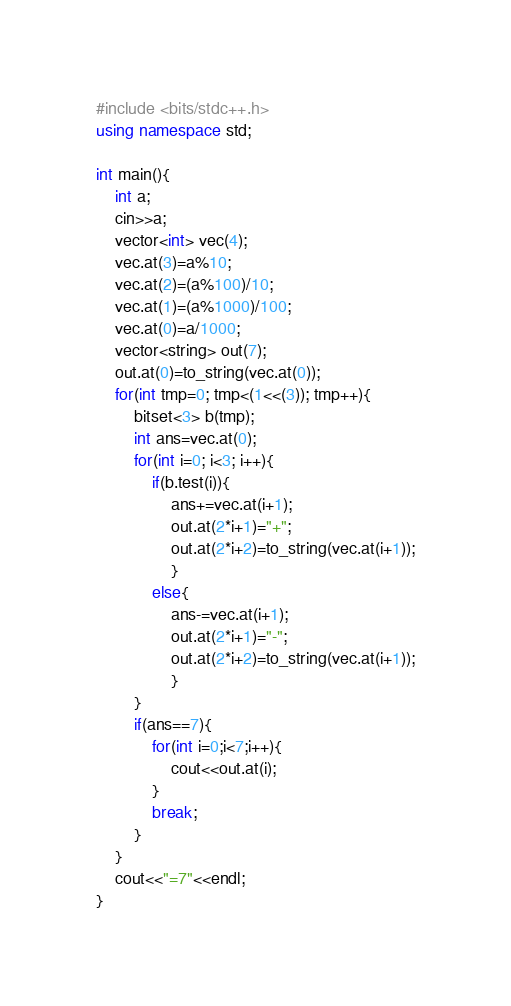Convert code to text. <code><loc_0><loc_0><loc_500><loc_500><_C++_>#include <bits/stdc++.h>
using namespace std;

int main(){
    int a;
    cin>>a;
    vector<int> vec(4);
    vec.at(3)=a%10;
    vec.at(2)=(a%100)/10;
    vec.at(1)=(a%1000)/100;
    vec.at(0)=a/1000;
    vector<string> out(7);
    out.at(0)=to_string(vec.at(0));
    for(int tmp=0; tmp<(1<<(3)); tmp++){
        bitset<3> b(tmp);
        int ans=vec.at(0);
        for(int i=0; i<3; i++){
            if(b.test(i)){
                ans+=vec.at(i+1);
                out.at(2*i+1)="+";
                out.at(2*i+2)=to_string(vec.at(i+1));
                }
            else{
                ans-=vec.at(i+1);
                out.at(2*i+1)="-";
                out.at(2*i+2)=to_string(vec.at(i+1));
                }
        }
        if(ans==7){
            for(int i=0;i<7;i++){
                cout<<out.at(i);
            }
            break;
        }
    }
    cout<<"=7"<<endl;
}
</code> 